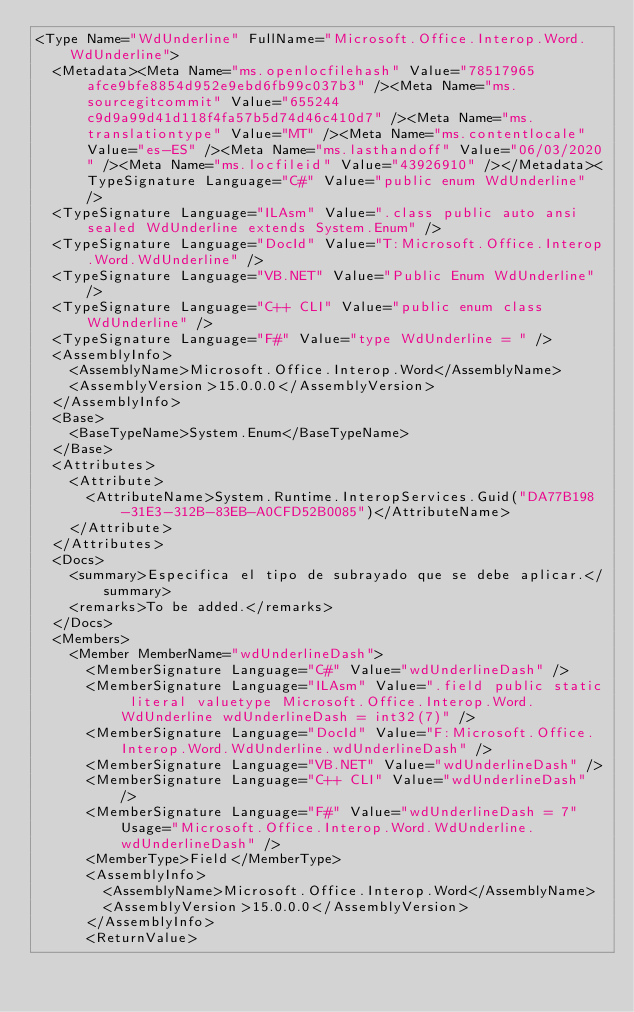<code> <loc_0><loc_0><loc_500><loc_500><_XML_><Type Name="WdUnderline" FullName="Microsoft.Office.Interop.Word.WdUnderline">
  <Metadata><Meta Name="ms.openlocfilehash" Value="78517965afce9bfe8854d952e9ebd6fb99c037b3" /><Meta Name="ms.sourcegitcommit" Value="655244c9d9a99d41d118f4fa57b5d74d46c410d7" /><Meta Name="ms.translationtype" Value="MT" /><Meta Name="ms.contentlocale" Value="es-ES" /><Meta Name="ms.lasthandoff" Value="06/03/2020" /><Meta Name="ms.locfileid" Value="43926910" /></Metadata><TypeSignature Language="C#" Value="public enum WdUnderline" />
  <TypeSignature Language="ILAsm" Value=".class public auto ansi sealed WdUnderline extends System.Enum" />
  <TypeSignature Language="DocId" Value="T:Microsoft.Office.Interop.Word.WdUnderline" />
  <TypeSignature Language="VB.NET" Value="Public Enum WdUnderline" />
  <TypeSignature Language="C++ CLI" Value="public enum class WdUnderline" />
  <TypeSignature Language="F#" Value="type WdUnderline = " />
  <AssemblyInfo>
    <AssemblyName>Microsoft.Office.Interop.Word</AssemblyName>
    <AssemblyVersion>15.0.0.0</AssemblyVersion>
  </AssemblyInfo>
  <Base>
    <BaseTypeName>System.Enum</BaseTypeName>
  </Base>
  <Attributes>
    <Attribute>
      <AttributeName>System.Runtime.InteropServices.Guid("DA77B198-31E3-312B-83EB-A0CFD52B0085")</AttributeName>
    </Attribute>
  </Attributes>
  <Docs>
    <summary>Especifica el tipo de subrayado que se debe aplicar.</summary>
    <remarks>To be added.</remarks>
  </Docs>
  <Members>
    <Member MemberName="wdUnderlineDash">
      <MemberSignature Language="C#" Value="wdUnderlineDash" />
      <MemberSignature Language="ILAsm" Value=".field public static literal valuetype Microsoft.Office.Interop.Word.WdUnderline wdUnderlineDash = int32(7)" />
      <MemberSignature Language="DocId" Value="F:Microsoft.Office.Interop.Word.WdUnderline.wdUnderlineDash" />
      <MemberSignature Language="VB.NET" Value="wdUnderlineDash" />
      <MemberSignature Language="C++ CLI" Value="wdUnderlineDash" />
      <MemberSignature Language="F#" Value="wdUnderlineDash = 7" Usage="Microsoft.Office.Interop.Word.WdUnderline.wdUnderlineDash" />
      <MemberType>Field</MemberType>
      <AssemblyInfo>
        <AssemblyName>Microsoft.Office.Interop.Word</AssemblyName>
        <AssemblyVersion>15.0.0.0</AssemblyVersion>
      </AssemblyInfo>
      <ReturnValue></code> 